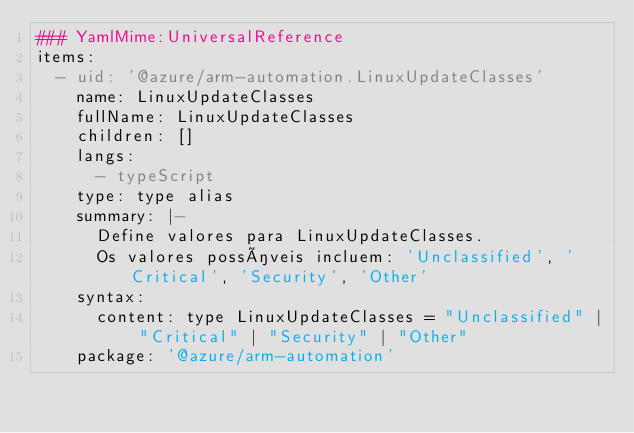Convert code to text. <code><loc_0><loc_0><loc_500><loc_500><_YAML_>### YamlMime:UniversalReference
items:
  - uid: '@azure/arm-automation.LinuxUpdateClasses'
    name: LinuxUpdateClasses
    fullName: LinuxUpdateClasses
    children: []
    langs:
      - typeScript
    type: type alias
    summary: |-
      Define valores para LinuxUpdateClasses.
      Os valores possíveis incluem: 'Unclassified', 'Critical', 'Security', 'Other'
    syntax:
      content: type LinuxUpdateClasses = "Unclassified" | "Critical" | "Security" | "Other"
    package: '@azure/arm-automation'</code> 